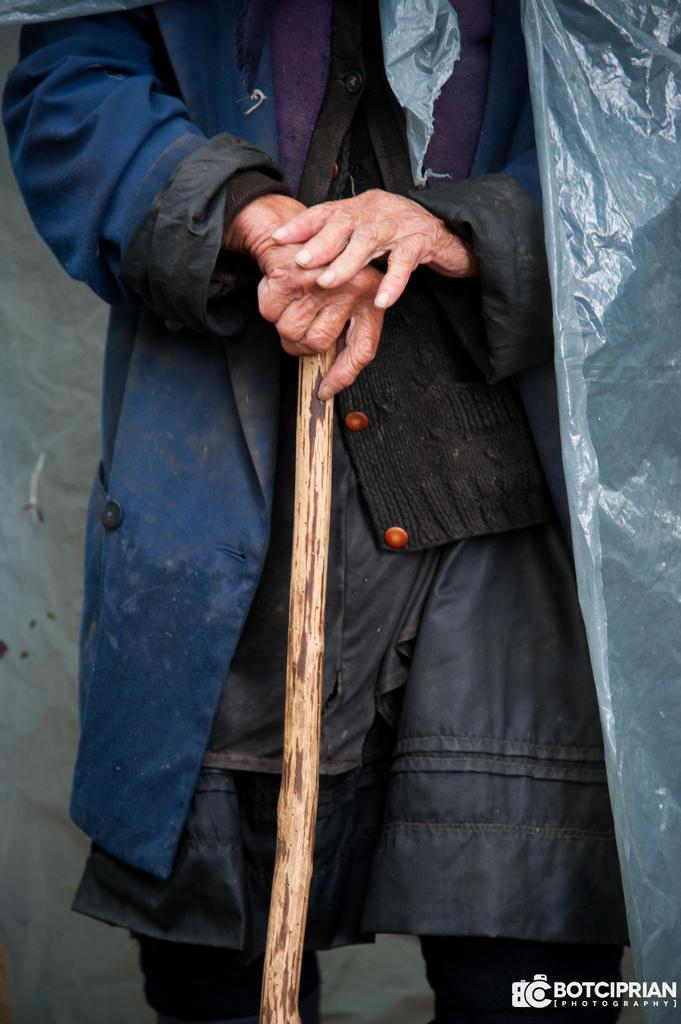What is the main subject of the image? The main subject of the image is a human standing. What is the human holding in the image? The human is holding a stick in the image. What type of clothing is the human wearing? The human is wearing a coat and a polythene cover in the image. Is there any text visible in the image? Yes, there is text at the bottom right corner of the image. What type of clam is being cooked on the stick in the image? There is no clam or cooking activity present in the image; the human is holding a stick without any food items. How many pancakes are visible on the coat of the human in the image? There are no pancakes present on the coat of the human in the image. 